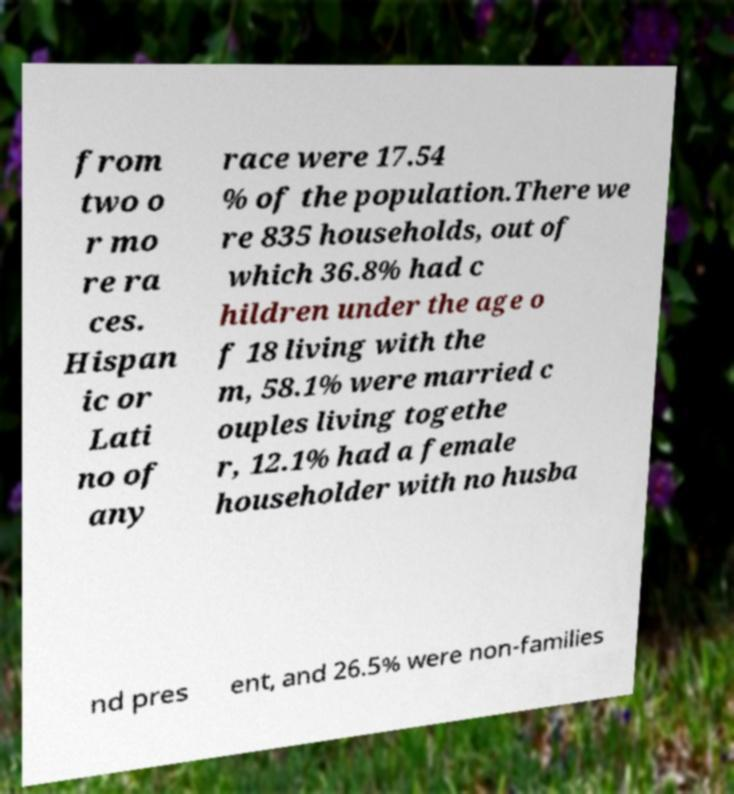Could you extract and type out the text from this image? from two o r mo re ra ces. Hispan ic or Lati no of any race were 17.54 % of the population.There we re 835 households, out of which 36.8% had c hildren under the age o f 18 living with the m, 58.1% were married c ouples living togethe r, 12.1% had a female householder with no husba nd pres ent, and 26.5% were non-families 